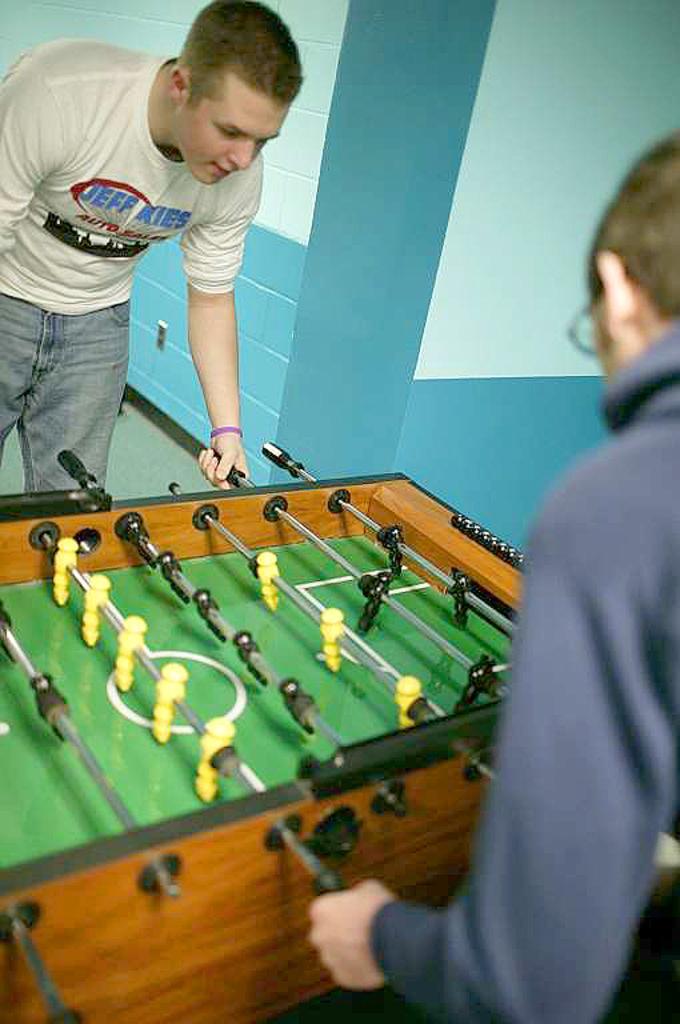In one or two sentences, can you explain what this image depicts? In the picture I can see two men are standing on the floor among them the man on the left side is holding an object in the hand. Here I can see a table football. In the background I can see a wall. 